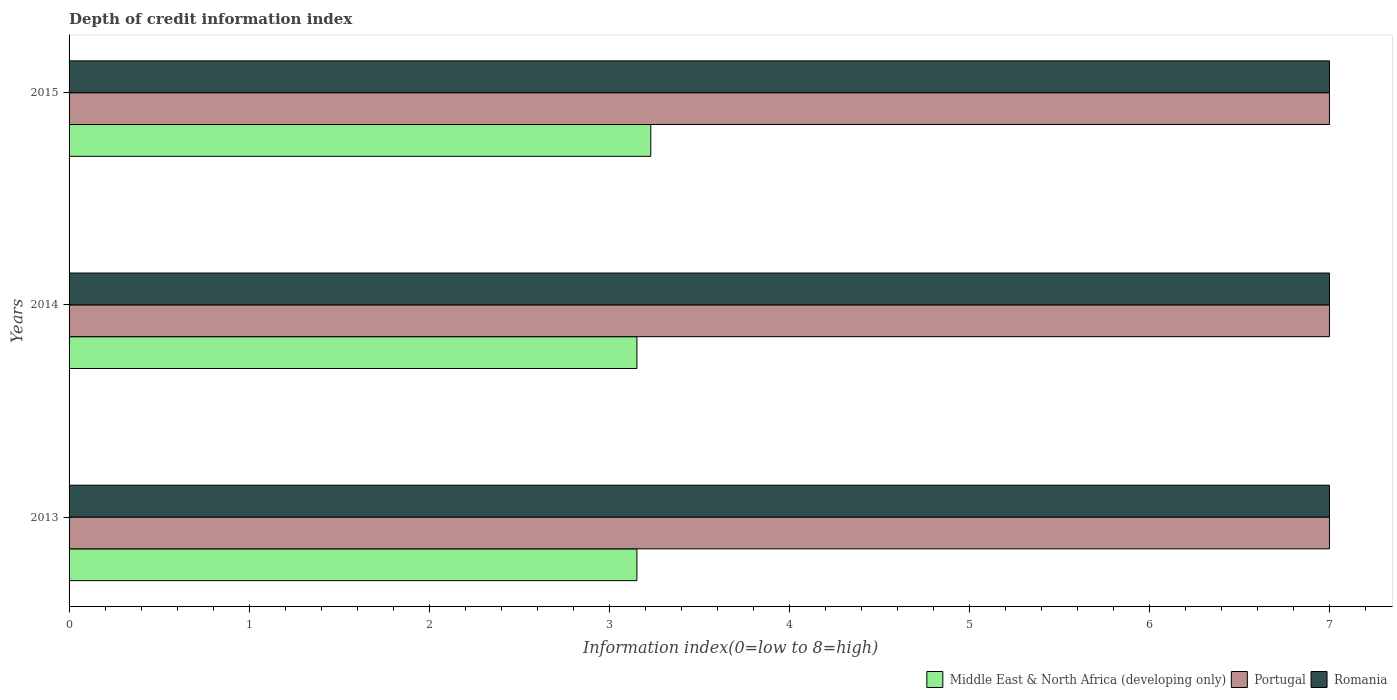How many different coloured bars are there?
Your answer should be very brief. 3. Are the number of bars on each tick of the Y-axis equal?
Provide a short and direct response. Yes. What is the label of the 3rd group of bars from the top?
Keep it short and to the point. 2013. In how many cases, is the number of bars for a given year not equal to the number of legend labels?
Ensure brevity in your answer.  0. What is the information index in Middle East & North Africa (developing only) in 2015?
Keep it short and to the point. 3.23. Across all years, what is the maximum information index in Romania?
Offer a terse response. 7. Across all years, what is the minimum information index in Portugal?
Ensure brevity in your answer.  7. In which year was the information index in Middle East & North Africa (developing only) maximum?
Offer a very short reply. 2015. In which year was the information index in Middle East & North Africa (developing only) minimum?
Offer a terse response. 2013. What is the total information index in Middle East & North Africa (developing only) in the graph?
Provide a short and direct response. 9.54. What is the difference between the information index in Middle East & North Africa (developing only) in 2013 and that in 2015?
Keep it short and to the point. -0.08. What is the difference between the information index in Romania in 2013 and the information index in Middle East & North Africa (developing only) in 2015?
Keep it short and to the point. 3.77. What is the average information index in Portugal per year?
Keep it short and to the point. 7. In the year 2013, what is the difference between the information index in Romania and information index in Middle East & North Africa (developing only)?
Offer a terse response. 3.85. What is the ratio of the information index in Middle East & North Africa (developing only) in 2013 to that in 2015?
Offer a terse response. 0.98. Is the information index in Romania in 2014 less than that in 2015?
Your answer should be compact. No. What is the difference between the highest and the lowest information index in Romania?
Offer a very short reply. 0. What does the 3rd bar from the top in 2014 represents?
Keep it short and to the point. Middle East & North Africa (developing only). What does the 1st bar from the bottom in 2015 represents?
Provide a succinct answer. Middle East & North Africa (developing only). Are all the bars in the graph horizontal?
Ensure brevity in your answer.  Yes. Does the graph contain grids?
Your response must be concise. No. How many legend labels are there?
Offer a very short reply. 3. What is the title of the graph?
Give a very brief answer. Depth of credit information index. What is the label or title of the X-axis?
Give a very brief answer. Information index(0=low to 8=high). What is the Information index(0=low to 8=high) in Middle East & North Africa (developing only) in 2013?
Your answer should be compact. 3.15. What is the Information index(0=low to 8=high) in Portugal in 2013?
Your answer should be compact. 7. What is the Information index(0=low to 8=high) in Middle East & North Africa (developing only) in 2014?
Give a very brief answer. 3.15. What is the Information index(0=low to 8=high) of Middle East & North Africa (developing only) in 2015?
Your response must be concise. 3.23. Across all years, what is the maximum Information index(0=low to 8=high) in Middle East & North Africa (developing only)?
Your response must be concise. 3.23. Across all years, what is the minimum Information index(0=low to 8=high) of Middle East & North Africa (developing only)?
Make the answer very short. 3.15. Across all years, what is the minimum Information index(0=low to 8=high) of Portugal?
Your answer should be very brief. 7. Across all years, what is the minimum Information index(0=low to 8=high) in Romania?
Offer a terse response. 7. What is the total Information index(0=low to 8=high) of Middle East & North Africa (developing only) in the graph?
Your response must be concise. 9.54. What is the total Information index(0=low to 8=high) in Romania in the graph?
Keep it short and to the point. 21. What is the difference between the Information index(0=low to 8=high) in Middle East & North Africa (developing only) in 2013 and that in 2015?
Your answer should be compact. -0.08. What is the difference between the Information index(0=low to 8=high) in Middle East & North Africa (developing only) in 2014 and that in 2015?
Your response must be concise. -0.08. What is the difference between the Information index(0=low to 8=high) of Middle East & North Africa (developing only) in 2013 and the Information index(0=low to 8=high) of Portugal in 2014?
Make the answer very short. -3.85. What is the difference between the Information index(0=low to 8=high) of Middle East & North Africa (developing only) in 2013 and the Information index(0=low to 8=high) of Romania in 2014?
Offer a terse response. -3.85. What is the difference between the Information index(0=low to 8=high) of Portugal in 2013 and the Information index(0=low to 8=high) of Romania in 2014?
Provide a short and direct response. 0. What is the difference between the Information index(0=low to 8=high) in Middle East & North Africa (developing only) in 2013 and the Information index(0=low to 8=high) in Portugal in 2015?
Provide a short and direct response. -3.85. What is the difference between the Information index(0=low to 8=high) of Middle East & North Africa (developing only) in 2013 and the Information index(0=low to 8=high) of Romania in 2015?
Offer a terse response. -3.85. What is the difference between the Information index(0=low to 8=high) of Middle East & North Africa (developing only) in 2014 and the Information index(0=low to 8=high) of Portugal in 2015?
Your response must be concise. -3.85. What is the difference between the Information index(0=low to 8=high) in Middle East & North Africa (developing only) in 2014 and the Information index(0=low to 8=high) in Romania in 2015?
Keep it short and to the point. -3.85. What is the difference between the Information index(0=low to 8=high) of Portugal in 2014 and the Information index(0=low to 8=high) of Romania in 2015?
Keep it short and to the point. 0. What is the average Information index(0=low to 8=high) of Middle East & North Africa (developing only) per year?
Keep it short and to the point. 3.18. In the year 2013, what is the difference between the Information index(0=low to 8=high) of Middle East & North Africa (developing only) and Information index(0=low to 8=high) of Portugal?
Provide a succinct answer. -3.85. In the year 2013, what is the difference between the Information index(0=low to 8=high) of Middle East & North Africa (developing only) and Information index(0=low to 8=high) of Romania?
Provide a short and direct response. -3.85. In the year 2013, what is the difference between the Information index(0=low to 8=high) in Portugal and Information index(0=low to 8=high) in Romania?
Keep it short and to the point. 0. In the year 2014, what is the difference between the Information index(0=low to 8=high) in Middle East & North Africa (developing only) and Information index(0=low to 8=high) in Portugal?
Provide a short and direct response. -3.85. In the year 2014, what is the difference between the Information index(0=low to 8=high) of Middle East & North Africa (developing only) and Information index(0=low to 8=high) of Romania?
Your answer should be very brief. -3.85. In the year 2015, what is the difference between the Information index(0=low to 8=high) of Middle East & North Africa (developing only) and Information index(0=low to 8=high) of Portugal?
Your answer should be compact. -3.77. In the year 2015, what is the difference between the Information index(0=low to 8=high) of Middle East & North Africa (developing only) and Information index(0=low to 8=high) of Romania?
Offer a terse response. -3.77. What is the ratio of the Information index(0=low to 8=high) in Middle East & North Africa (developing only) in 2013 to that in 2015?
Ensure brevity in your answer.  0.98. What is the ratio of the Information index(0=low to 8=high) in Portugal in 2013 to that in 2015?
Ensure brevity in your answer.  1. What is the ratio of the Information index(0=low to 8=high) in Middle East & North Africa (developing only) in 2014 to that in 2015?
Your answer should be very brief. 0.98. What is the difference between the highest and the second highest Information index(0=low to 8=high) in Middle East & North Africa (developing only)?
Make the answer very short. 0.08. What is the difference between the highest and the second highest Information index(0=low to 8=high) in Portugal?
Provide a short and direct response. 0. What is the difference between the highest and the second highest Information index(0=low to 8=high) in Romania?
Keep it short and to the point. 0. What is the difference between the highest and the lowest Information index(0=low to 8=high) in Middle East & North Africa (developing only)?
Your answer should be very brief. 0.08. What is the difference between the highest and the lowest Information index(0=low to 8=high) in Romania?
Give a very brief answer. 0. 